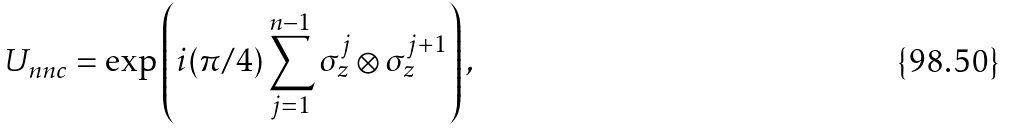<formula> <loc_0><loc_0><loc_500><loc_500>U _ { n n c } = \exp \left ( i ( \pi / 4 ) \sum ^ { n - 1 } _ { j = 1 } \sigma _ { z } ^ { j } \otimes \sigma _ { z } ^ { j + 1 } \right ) ,</formula> 